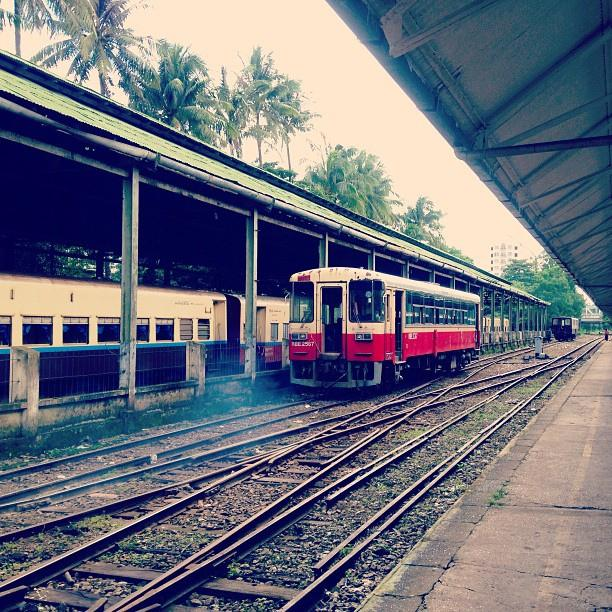Which word best describes this train station?

Choices:
A) new
B) alive
C) decrepit
D) bustling decrepit 